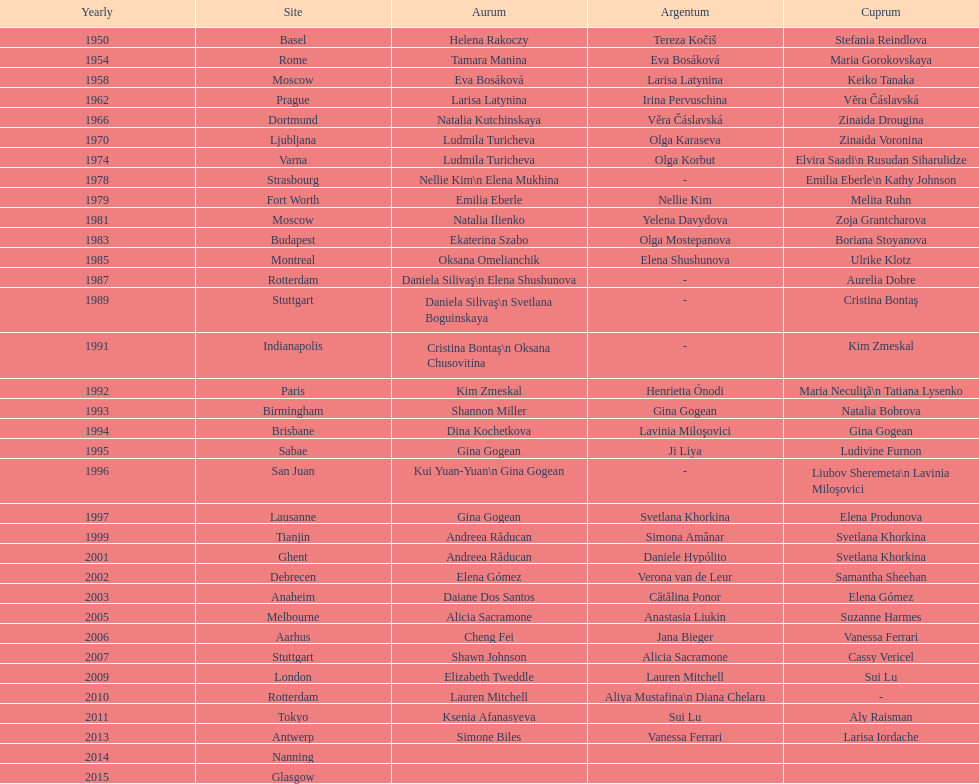How many times was the world artistic gymnastics championships held in the united states? 3. 